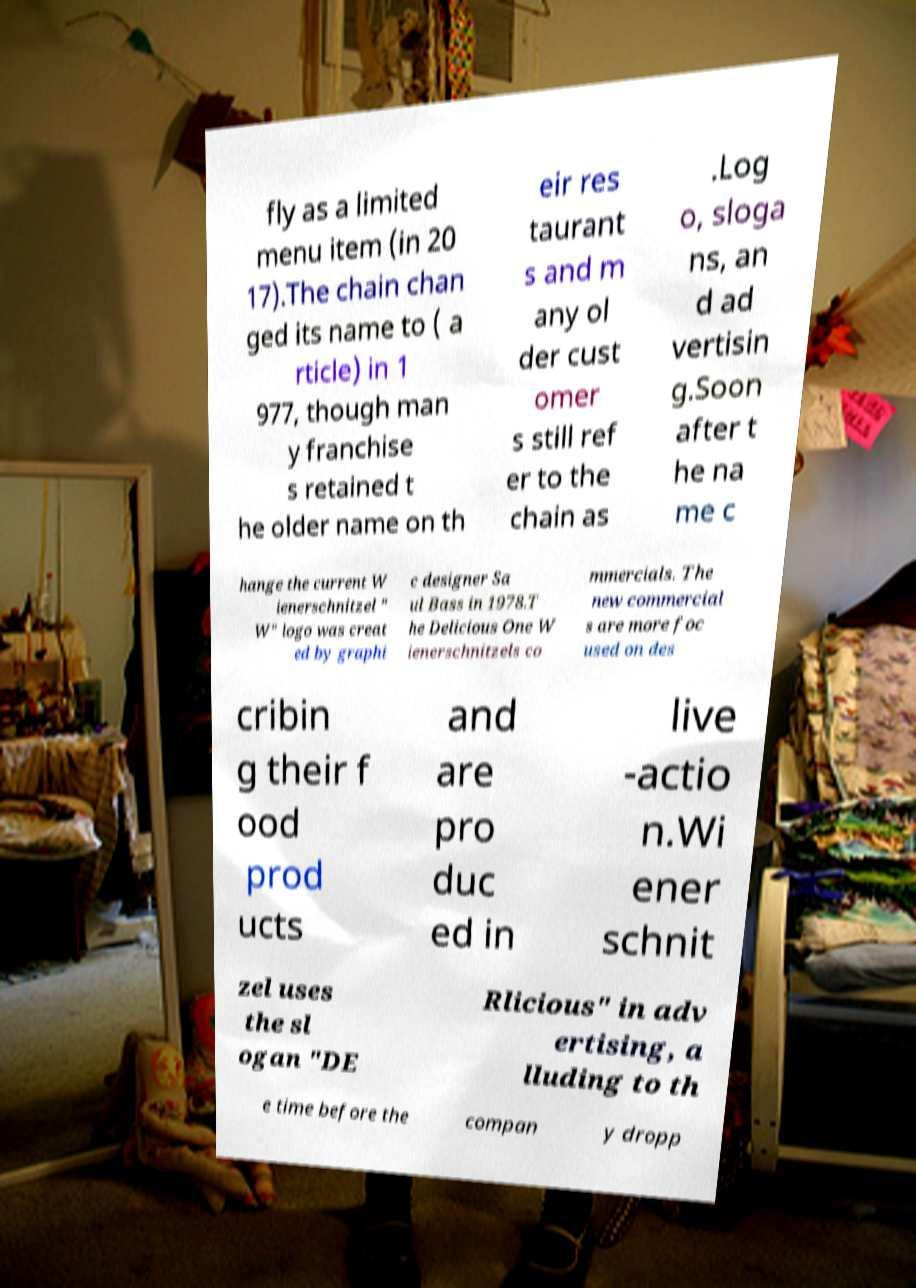Please read and relay the text visible in this image. What does it say? fly as a limited menu item (in 20 17).The chain chan ged its name to ( a rticle) in 1 977, though man y franchise s retained t he older name on th eir res taurant s and m any ol der cust omer s still ref er to the chain as .Log o, sloga ns, an d ad vertisin g.Soon after t he na me c hange the current W ienerschnitzel " W" logo was creat ed by graphi c designer Sa ul Bass in 1978.T he Delicious One W ienerschnitzels co mmercials. The new commercial s are more foc used on des cribin g their f ood prod ucts and are pro duc ed in live -actio n.Wi ener schnit zel uses the sl ogan "DE Rlicious" in adv ertising, a lluding to th e time before the compan y dropp 